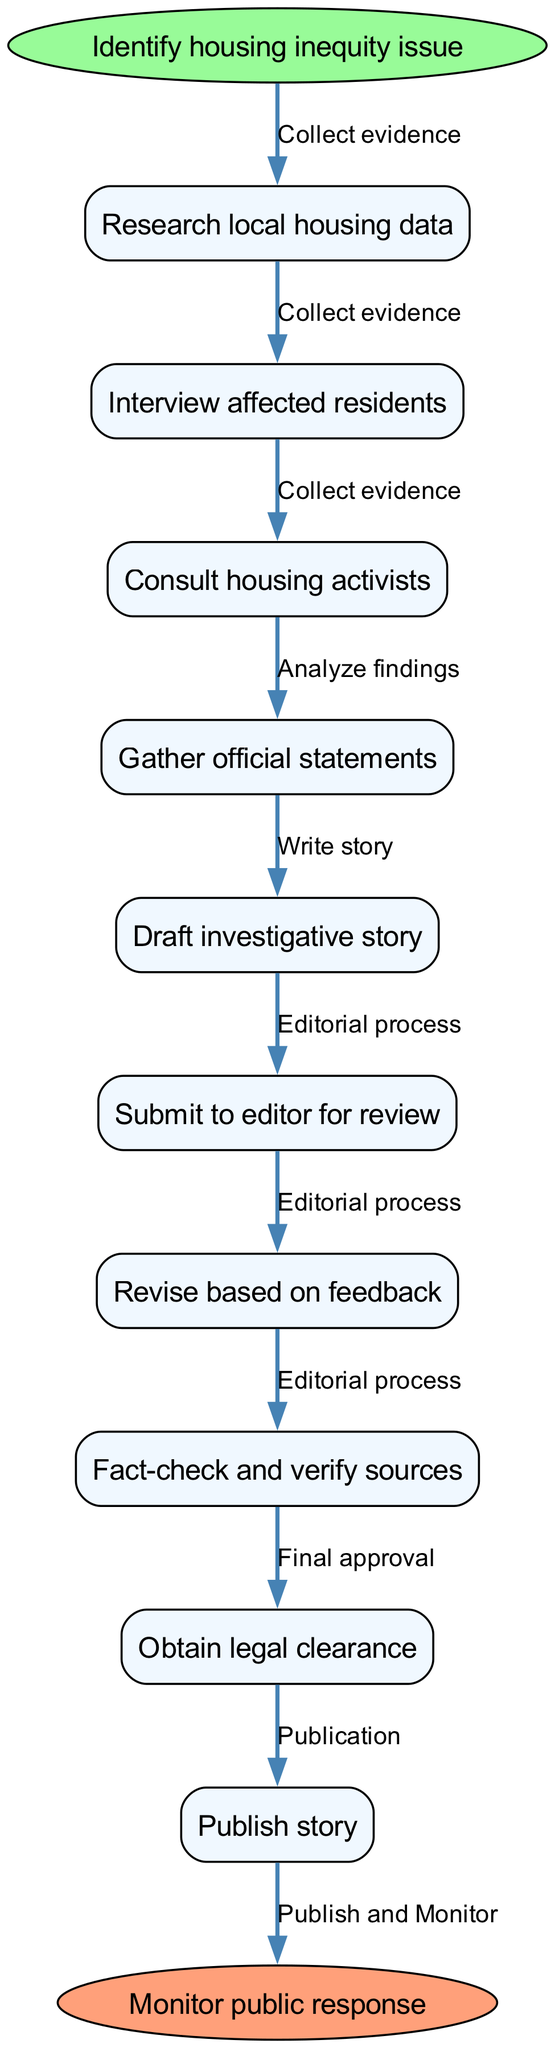What is the starting point of the diagram? The starting point, as indicated at the top of the diagram, is "Identify housing inequity issue".
Answer: Identify housing inequity issue How many nodes are present in the diagram? The diagram contains a total of ten nodes including the start and end nodes, with eight main nodes in between.
Answer: Ten What is the second node in the sequence? The second node in the sequence after "Identify housing inequity issue" is "Research local housing data".
Answer: Research local housing data What is the last step before the story is published? The last step before publication is "Obtain legal clearance", as shown in the final sequence before reaching the end node.
Answer: Obtain legal clearance Which node directly follows "Draft investigative story"? The node that directly follows "Draft investigative story" is "Submit to editor for review".
Answer: Submit to editor for review What edge connects "Gather official statements" to "Draft investigative story"? The edge that connects these two nodes is labeled as "Write story".
Answer: Write story How many edges are there in total? There are six edges in total that connect the nodes throughout the diagram.
Answer: Six Which nodes are linked by the edge labeled "Editorial process"? The edge labeled "Editorial process" links the nodes "Submit to editor for review" and "Revise based on feedback".
Answer: Submit to editor for review and Revise based on feedback What is the final action mentioned at the end of the diagram? The final action mentioned at the end of the diagram is "Monitor public response".
Answer: Monitor public response 